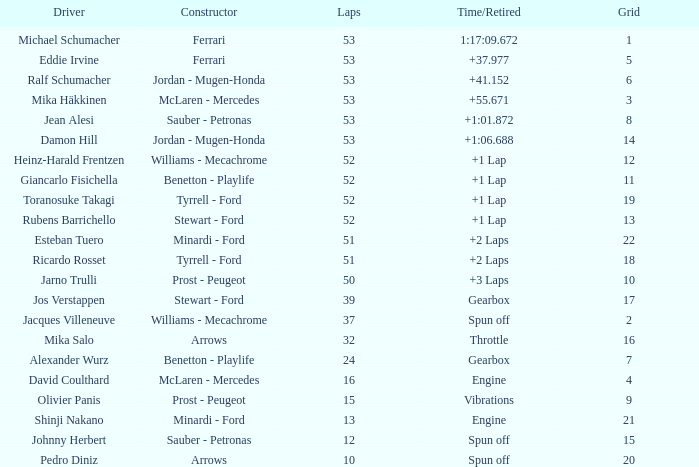What is the grid total for ralf schumacher participating in 53 laps? None. 